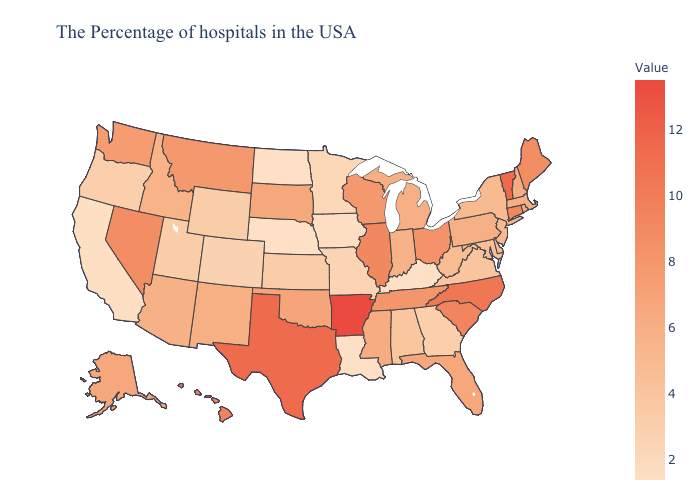Among the states that border Arkansas , which have the highest value?
Keep it brief. Texas. Among the states that border North Dakota , which have the highest value?
Answer briefly. Montana. Does Florida have a lower value than Alabama?
Short answer required. No. Is the legend a continuous bar?
Short answer required. Yes. Does Rhode Island have a higher value than Arkansas?
Short answer required. No. Does Arkansas have the highest value in the USA?
Quick response, please. Yes. 